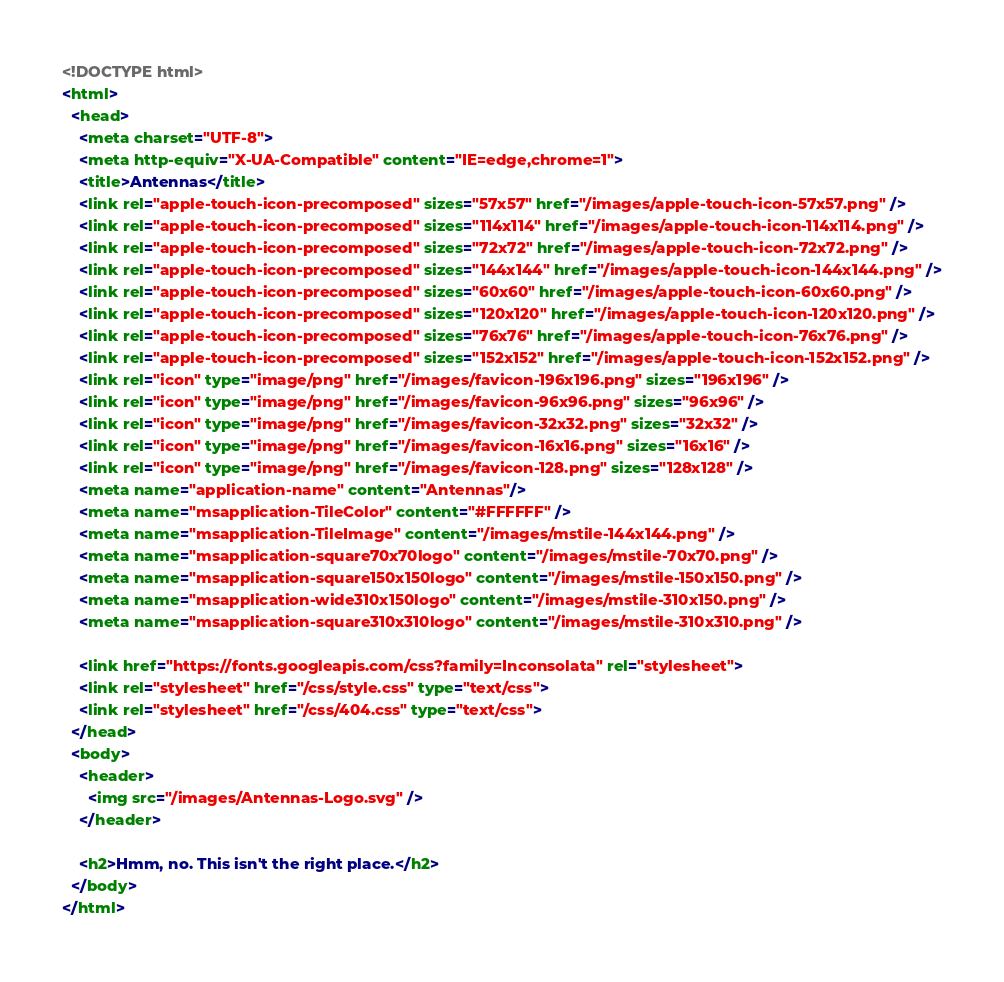<code> <loc_0><loc_0><loc_500><loc_500><_HTML_><!DOCTYPE html>
<html>
  <head>
    <meta charset="UTF-8">
    <meta http-equiv="X-UA-Compatible" content="IE=edge,chrome=1">
    <title>Antennas</title>
    <link rel="apple-touch-icon-precomposed" sizes="57x57" href="/images/apple-touch-icon-57x57.png" />
    <link rel="apple-touch-icon-precomposed" sizes="114x114" href="/images/apple-touch-icon-114x114.png" />
    <link rel="apple-touch-icon-precomposed" sizes="72x72" href="/images/apple-touch-icon-72x72.png" />
    <link rel="apple-touch-icon-precomposed" sizes="144x144" href="/images/apple-touch-icon-144x144.png" />
    <link rel="apple-touch-icon-precomposed" sizes="60x60" href="/images/apple-touch-icon-60x60.png" />
    <link rel="apple-touch-icon-precomposed" sizes="120x120" href="/images/apple-touch-icon-120x120.png" />
    <link rel="apple-touch-icon-precomposed" sizes="76x76" href="/images/apple-touch-icon-76x76.png" />
    <link rel="apple-touch-icon-precomposed" sizes="152x152" href="/images/apple-touch-icon-152x152.png" />
    <link rel="icon" type="image/png" href="/images/favicon-196x196.png" sizes="196x196" />
    <link rel="icon" type="image/png" href="/images/favicon-96x96.png" sizes="96x96" />
    <link rel="icon" type="image/png" href="/images/favicon-32x32.png" sizes="32x32" />
    <link rel="icon" type="image/png" href="/images/favicon-16x16.png" sizes="16x16" />
    <link rel="icon" type="image/png" href="/images/favicon-128.png" sizes="128x128" />
    <meta name="application-name" content="Antennas"/>
    <meta name="msapplication-TileColor" content="#FFFFFF" />
    <meta name="msapplication-TileImage" content="/images/mstile-144x144.png" />
    <meta name="msapplication-square70x70logo" content="/images/mstile-70x70.png" />
    <meta name="msapplication-square150x150logo" content="/images/mstile-150x150.png" />
    <meta name="msapplication-wide310x150logo" content="/images/mstile-310x150.png" />
    <meta name="msapplication-square310x310logo" content="/images/mstile-310x310.png" />

    <link href="https://fonts.googleapis.com/css?family=Inconsolata" rel="stylesheet">
    <link rel="stylesheet" href="/css/style.css" type="text/css">
    <link rel="stylesheet" href="/css/404.css" type="text/css">
  </head>
  <body>
    <header>
      <img src="/images/Antennas-Logo.svg" />
    </header>

    <h2>Hmm, no. This isn't the right place.</h2>
  </body>
</html>
</code> 